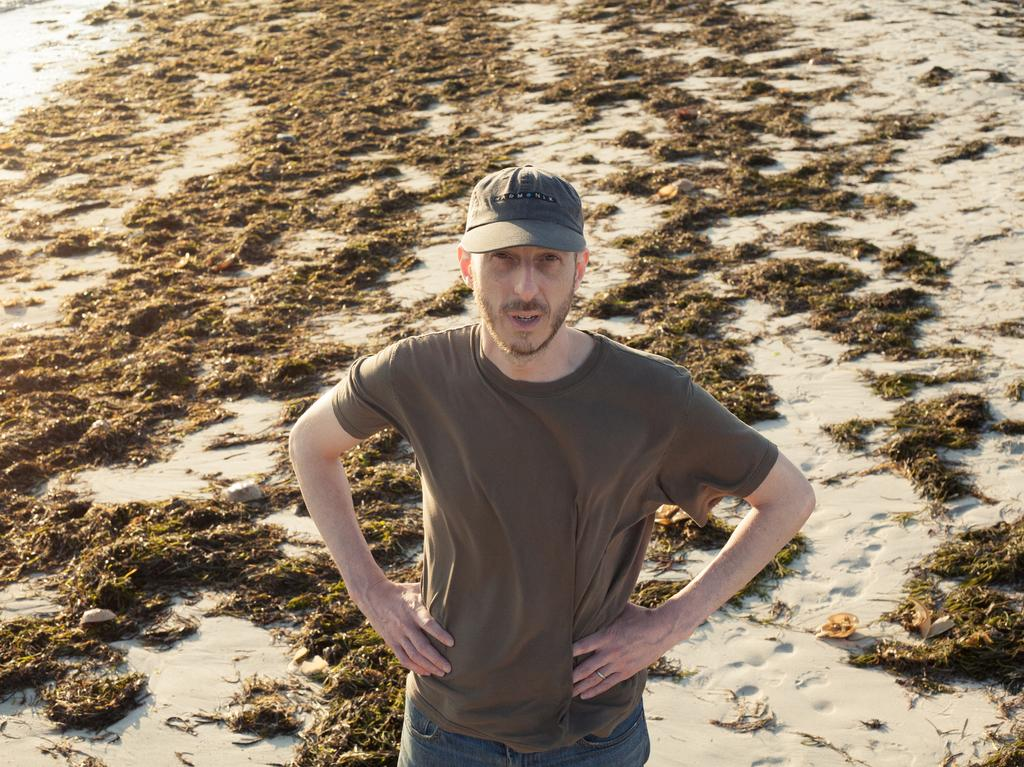Who is present in the image? There is a man in the image. What is the man wearing on his head? The man is wearing a cap. What type of surface is visible behind the man? There is grass on the ground behind the man. How many trees can be seen behind the man in the image? There are no trees visible in the image; only grass is present on the ground behind the man. 